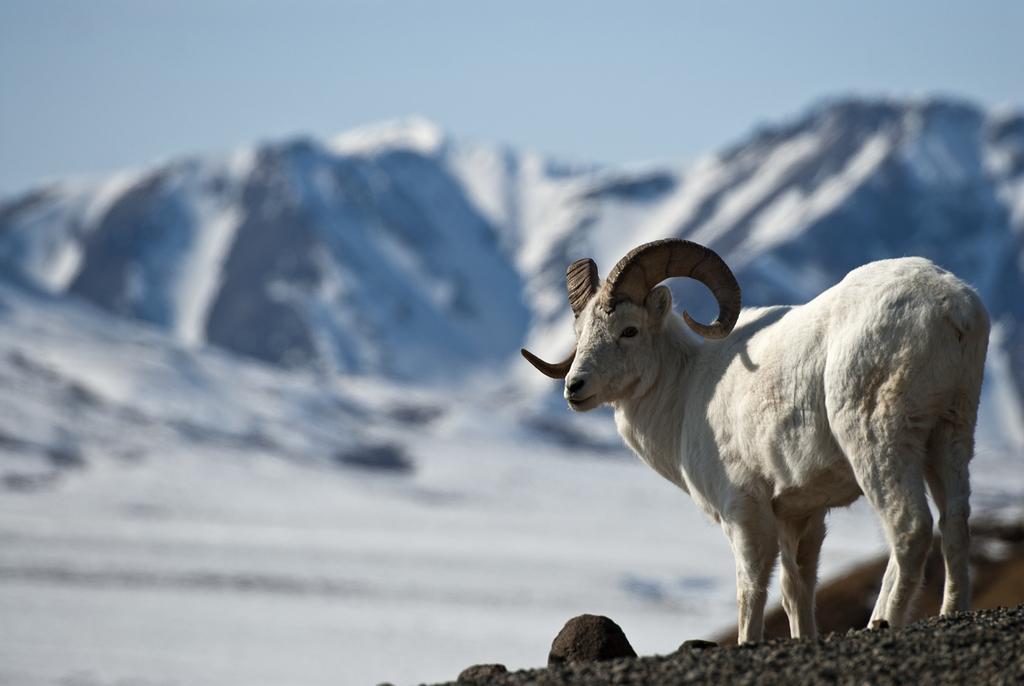Could you give a brief overview of what you see in this image? In the image in the center, we can see one goat, which is in white color. In the background we can see the sky and hills. 